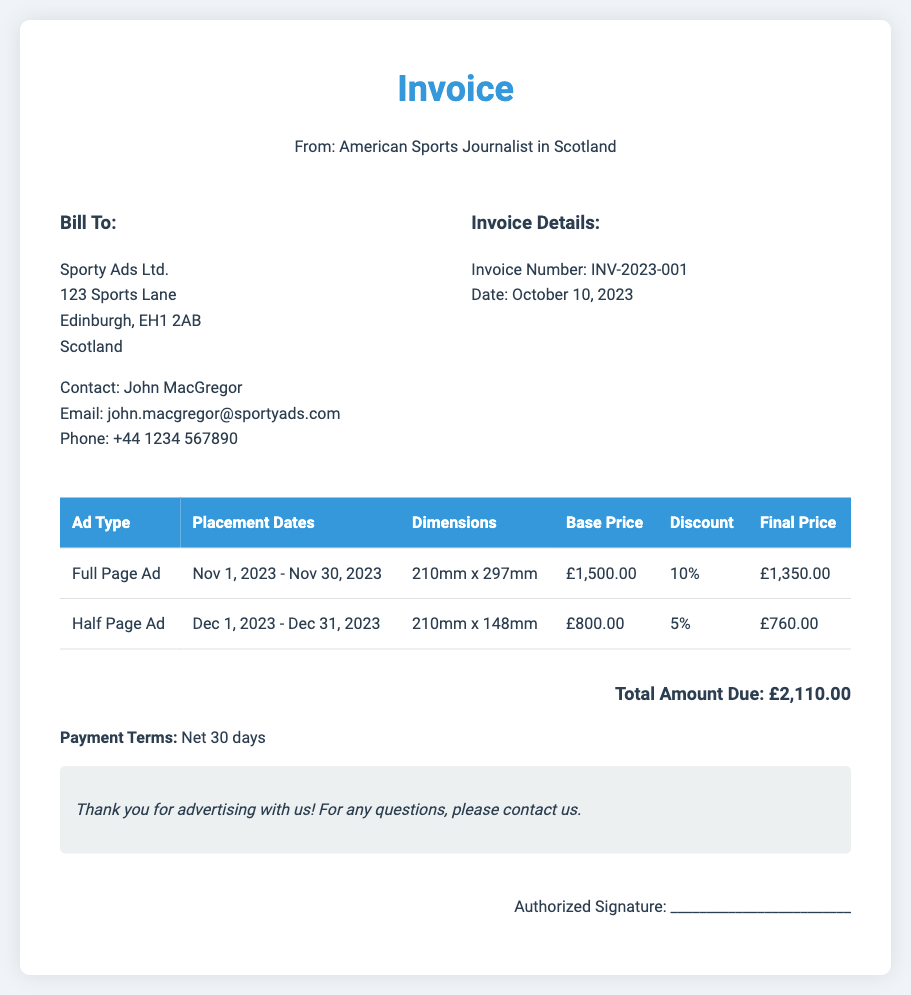What is the invoice number? The invoice number is listed in the invoice details section.
Answer: INV-2023-001 Who is billed for the advertising space? The entity being billed is mentioned in the "Bill To" section.
Answer: Sporty Ads Ltd What are the placement dates for the full page ad? The placement dates are specified in the table under the column for placement dates.
Answer: Nov 1, 2023 - Nov 30, 2023 What is the base price for the half page ad? The base price is indicated in the pricing section for the half page ad.
Answer: £800.00 How much is the final price for the full page ad after discount? The final price is shown in the table under the final price column for the full page ad.
Answer: £1,350.00 What is the total amount due? The total amount due is clearly stated at the bottom of the invoice.
Answer: £2,110.00 What discount is applied to the half page ad? The discount applied is stated in the pricing structure for the half page ad.
Answer: 5% What is the payment term specified in the document? Payment terms are noted in a separate section of the document.
Answer: Net 30 days What is the dimension for a full page ad? The dimensions for the full page ad are listed in the table under the dimensions column.
Answer: 210mm x 297mm 